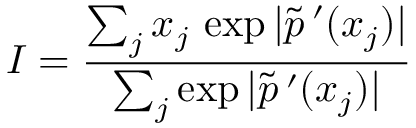Convert formula to latex. <formula><loc_0><loc_0><loc_500><loc_500>I = \frac { \sum _ { j } x _ { j } \, \exp | \tilde { p } \, ^ { \prime } ( x _ { j } ) | } { \sum _ { j } \exp | \tilde { p } \, ^ { \prime } ( x _ { j } ) | }</formula> 